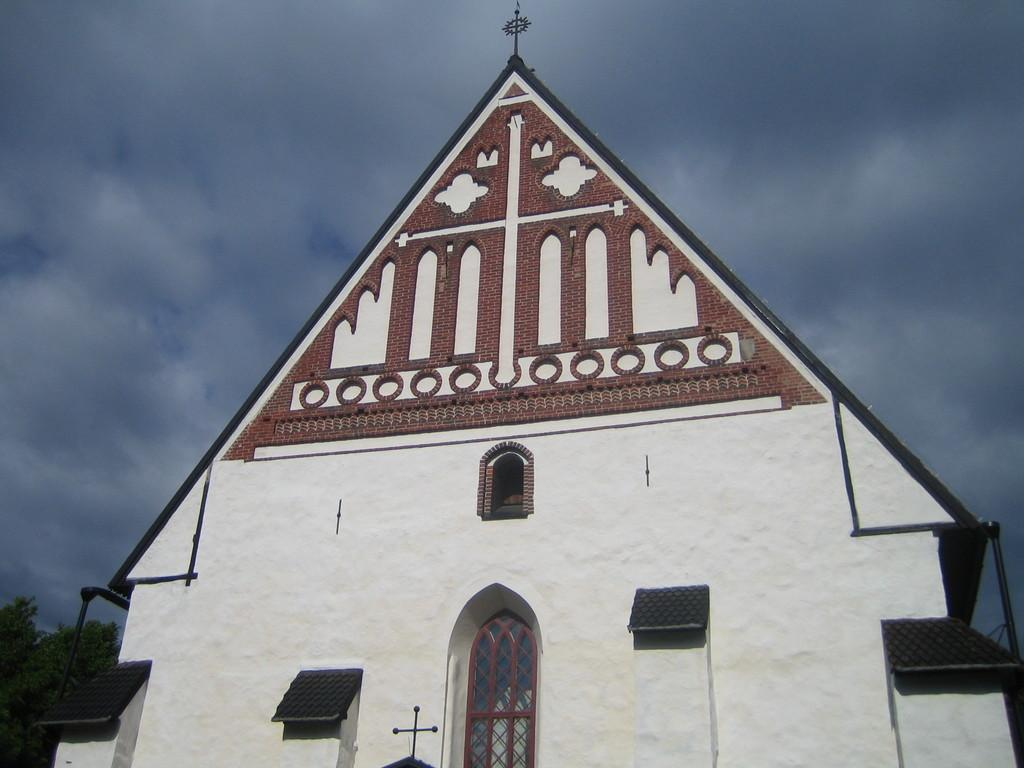What type of structure is in the image? There is a building in the image. What colors are used for the building? The building is in white and brown color. What can be seen on the left side of the image? There are trees on the left side of the image. What is visible in the background of the image? There is a sky visible in the background of the image. What can be observed in the sky? There are clouds in the sky. How does the zoo increase the number of animals in the image? There is no zoo present in the image, and therefore no animals or increase in numbers can be observed. What type of light is used to illuminate the building in the image? The image does not provide information about the type of light used to illuminate the building. 